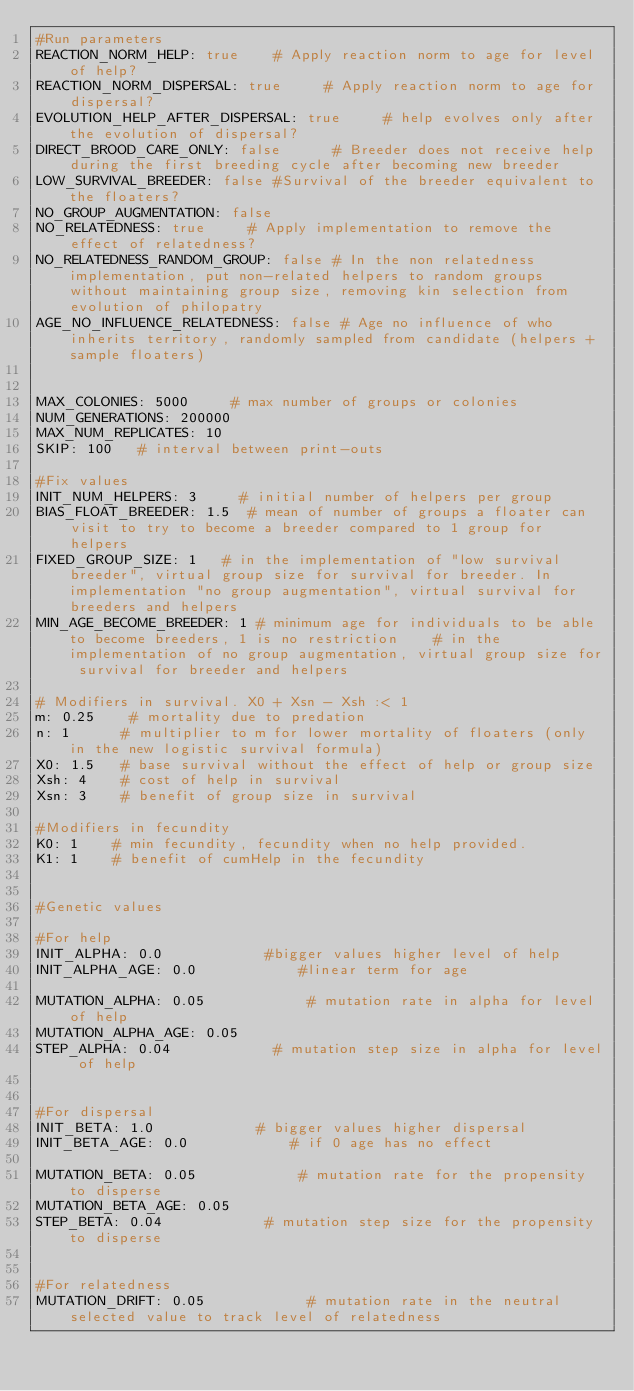Convert code to text. <code><loc_0><loc_0><loc_500><loc_500><_YAML_>#Run parameters
REACTION_NORM_HELP: true    # Apply reaction norm to age for level of help?
REACTION_NORM_DISPERSAL: true     # Apply reaction norm to age for dispersal?
EVOLUTION_HELP_AFTER_DISPERSAL: true     # help evolves only after the evolution of dispersal?
DIRECT_BROOD_CARE_ONLY: false      # Breeder does not receive help during the first breeding cycle after becoming new breeder
LOW_SURVIVAL_BREEDER: false #Survival of the breeder equivalent to the floaters?
NO_GROUP_AUGMENTATION: false
NO_RELATEDNESS: true     # Apply implementation to remove the effect of relatedness?
NO_RELATEDNESS_RANDOM_GROUP: false # In the non relatedness implementation, put non-related helpers to random groups without maintaining group size, removing kin selection from evolution of philopatry
AGE_NO_INFLUENCE_RELATEDNESS: false # Age no influence of who inherits territory, randomly sampled from candidate (helpers + sample floaters)


MAX_COLONIES: 5000     # max number of groups or colonies
NUM_GENERATIONS: 200000
MAX_NUM_REPLICATES: 10
SKIP: 100   # interval between print-outs

#Fix values
INIT_NUM_HELPERS: 3     # initial number of helpers per group
BIAS_FLOAT_BREEDER: 1.5  # mean of number of groups a floater can visit to try to become a breeder compared to 1 group for helpers
FIXED_GROUP_SIZE: 1		# in the implementation of "low survival breeder", virtual group size for survival for breeder. In implementation "no group augmentation", virtual survival for breeders and helpers
MIN_AGE_BECOME_BREEDER: 1 # minimum age for individuals to be able to become breeders, 1 is no restriction		# in the implementation of no group augmentation, virtual group size for survival for breeder and helpers

# Modifiers in survival. X0 + Xsn - Xsh :< 1
m: 0.25    # mortality due to predation
n: 1      # multiplier to m for lower mortality of floaters (only in the new logistic survival formula)
X0: 1.5   # base survival without the effect of help or group size
Xsh: 4    # cost of help in survival
Xsn: 3    # benefit of group size in survival

#Modifiers in fecundity
K0: 1    # min fecundity, fecundity when no help provided.
K1: 1    # benefit of cumHelp in the fecundity


#Genetic values

#For help
INIT_ALPHA: 0.0            #bigger values higher level of help
INIT_ALPHA_AGE: 0.0            #linear term for age

MUTATION_ALPHA: 0.05            # mutation rate in alpha for level of help
MUTATION_ALPHA_AGE: 0.05
STEP_ALPHA: 0.04            # mutation step size in alpha for level of help


#For dispersal
INIT_BETA: 1.0            # bigger values higher dispersal
INIT_BETA_AGE: 0.0            # if 0 age has no effect

MUTATION_BETA: 0.05            # mutation rate for the propensity to disperse
MUTATION_BETA_AGE: 0.05
STEP_BETA: 0.04            # mutation step size for the propensity to disperse


#For relatedness
MUTATION_DRIFT: 0.05            # mutation rate in the neutral selected value to track level of relatedness</code> 